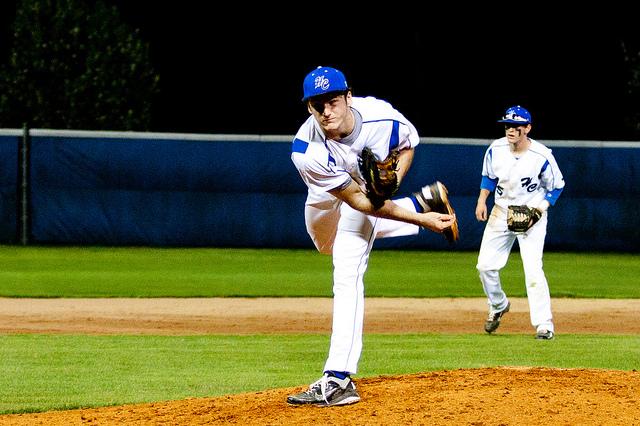What is the throwing handedness of the shortstop?
Quick response, please. Right. What color of uniform is the pitcher wearing?
Keep it brief. White and blue. What color is the pitcher's hat?
Answer briefly. Blue. 